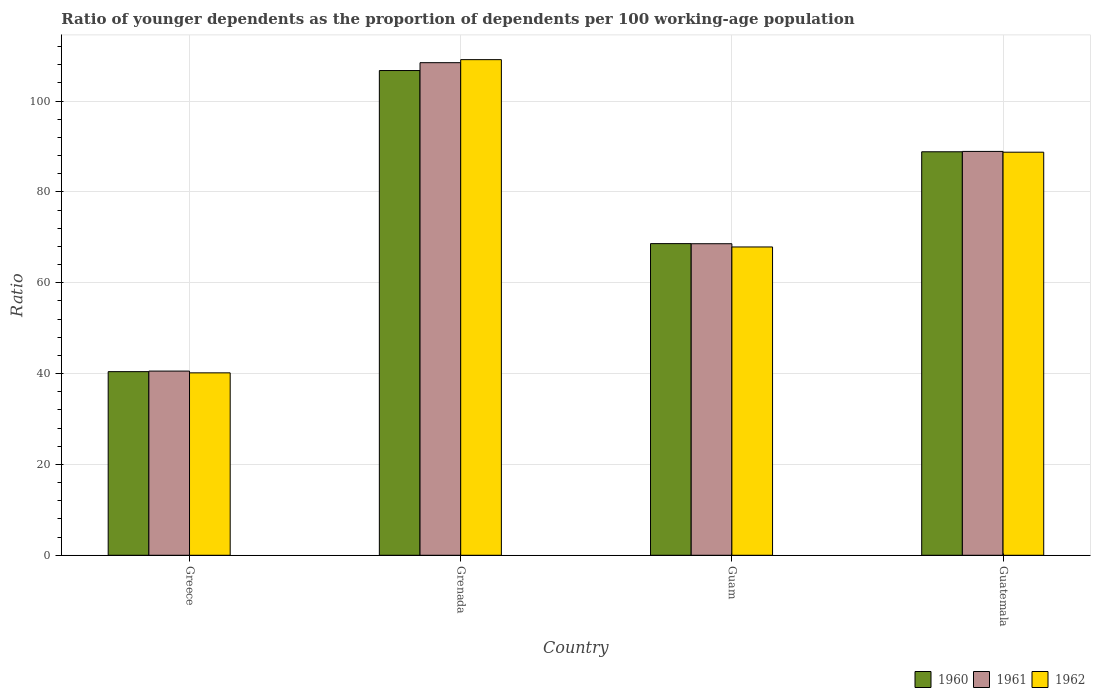How many different coloured bars are there?
Keep it short and to the point. 3. How many groups of bars are there?
Keep it short and to the point. 4. Are the number of bars per tick equal to the number of legend labels?
Your response must be concise. Yes. Are the number of bars on each tick of the X-axis equal?
Make the answer very short. Yes. How many bars are there on the 3rd tick from the right?
Give a very brief answer. 3. What is the label of the 3rd group of bars from the left?
Give a very brief answer. Guam. What is the age dependency ratio(young) in 1962 in Guatemala?
Make the answer very short. 88.73. Across all countries, what is the maximum age dependency ratio(young) in 1962?
Provide a short and direct response. 109.11. Across all countries, what is the minimum age dependency ratio(young) in 1962?
Make the answer very short. 40.16. In which country was the age dependency ratio(young) in 1962 maximum?
Give a very brief answer. Grenada. What is the total age dependency ratio(young) in 1961 in the graph?
Give a very brief answer. 306.48. What is the difference between the age dependency ratio(young) in 1960 in Grenada and that in Guam?
Make the answer very short. 38.1. What is the difference between the age dependency ratio(young) in 1961 in Greece and the age dependency ratio(young) in 1960 in Grenada?
Your response must be concise. -66.16. What is the average age dependency ratio(young) in 1962 per country?
Ensure brevity in your answer.  76.47. What is the difference between the age dependency ratio(young) of/in 1962 and age dependency ratio(young) of/in 1961 in Guatemala?
Your answer should be very brief. -0.17. What is the ratio of the age dependency ratio(young) in 1961 in Grenada to that in Guam?
Your answer should be very brief. 1.58. Is the age dependency ratio(young) in 1962 in Guam less than that in Guatemala?
Your answer should be very brief. Yes. What is the difference between the highest and the second highest age dependency ratio(young) in 1960?
Offer a terse response. -17.88. What is the difference between the highest and the lowest age dependency ratio(young) in 1962?
Provide a short and direct response. 68.95. Is the sum of the age dependency ratio(young) in 1961 in Greece and Guatemala greater than the maximum age dependency ratio(young) in 1962 across all countries?
Your answer should be very brief. Yes. What does the 2nd bar from the left in Guatemala represents?
Your response must be concise. 1961. What does the 2nd bar from the right in Guam represents?
Offer a terse response. 1961. Is it the case that in every country, the sum of the age dependency ratio(young) in 1961 and age dependency ratio(young) in 1962 is greater than the age dependency ratio(young) in 1960?
Ensure brevity in your answer.  Yes. What is the difference between two consecutive major ticks on the Y-axis?
Offer a terse response. 20. Does the graph contain grids?
Offer a very short reply. Yes. Where does the legend appear in the graph?
Your answer should be compact. Bottom right. How many legend labels are there?
Keep it short and to the point. 3. What is the title of the graph?
Your answer should be very brief. Ratio of younger dependents as the proportion of dependents per 100 working-age population. Does "2011" appear as one of the legend labels in the graph?
Ensure brevity in your answer.  No. What is the label or title of the Y-axis?
Your answer should be very brief. Ratio. What is the Ratio of 1960 in Greece?
Make the answer very short. 40.42. What is the Ratio in 1961 in Greece?
Ensure brevity in your answer.  40.55. What is the Ratio of 1962 in Greece?
Offer a terse response. 40.16. What is the Ratio of 1960 in Grenada?
Give a very brief answer. 106.71. What is the Ratio in 1961 in Grenada?
Offer a very short reply. 108.44. What is the Ratio of 1962 in Grenada?
Provide a succinct answer. 109.11. What is the Ratio in 1960 in Guam?
Your answer should be compact. 68.61. What is the Ratio of 1961 in Guam?
Make the answer very short. 68.58. What is the Ratio of 1962 in Guam?
Make the answer very short. 67.87. What is the Ratio in 1960 in Guatemala?
Offer a very short reply. 88.83. What is the Ratio in 1961 in Guatemala?
Make the answer very short. 88.91. What is the Ratio in 1962 in Guatemala?
Provide a succinct answer. 88.73. Across all countries, what is the maximum Ratio of 1960?
Your answer should be compact. 106.71. Across all countries, what is the maximum Ratio of 1961?
Keep it short and to the point. 108.44. Across all countries, what is the maximum Ratio in 1962?
Offer a very short reply. 109.11. Across all countries, what is the minimum Ratio of 1960?
Ensure brevity in your answer.  40.42. Across all countries, what is the minimum Ratio of 1961?
Give a very brief answer. 40.55. Across all countries, what is the minimum Ratio of 1962?
Provide a short and direct response. 40.16. What is the total Ratio of 1960 in the graph?
Offer a terse response. 304.56. What is the total Ratio in 1961 in the graph?
Keep it short and to the point. 306.48. What is the total Ratio of 1962 in the graph?
Ensure brevity in your answer.  305.87. What is the difference between the Ratio of 1960 in Greece and that in Grenada?
Keep it short and to the point. -66.29. What is the difference between the Ratio in 1961 in Greece and that in Grenada?
Your answer should be compact. -67.89. What is the difference between the Ratio of 1962 in Greece and that in Grenada?
Offer a very short reply. -68.95. What is the difference between the Ratio in 1960 in Greece and that in Guam?
Keep it short and to the point. -28.18. What is the difference between the Ratio of 1961 in Greece and that in Guam?
Offer a very short reply. -28.04. What is the difference between the Ratio of 1962 in Greece and that in Guam?
Your answer should be compact. -27.71. What is the difference between the Ratio of 1960 in Greece and that in Guatemala?
Your answer should be compact. -48.4. What is the difference between the Ratio of 1961 in Greece and that in Guatemala?
Your response must be concise. -48.36. What is the difference between the Ratio in 1962 in Greece and that in Guatemala?
Provide a short and direct response. -48.57. What is the difference between the Ratio of 1960 in Grenada and that in Guam?
Your answer should be very brief. 38.1. What is the difference between the Ratio in 1961 in Grenada and that in Guam?
Provide a short and direct response. 39.86. What is the difference between the Ratio of 1962 in Grenada and that in Guam?
Keep it short and to the point. 41.23. What is the difference between the Ratio in 1960 in Grenada and that in Guatemala?
Give a very brief answer. 17.88. What is the difference between the Ratio in 1961 in Grenada and that in Guatemala?
Make the answer very short. 19.53. What is the difference between the Ratio in 1962 in Grenada and that in Guatemala?
Give a very brief answer. 20.37. What is the difference between the Ratio in 1960 in Guam and that in Guatemala?
Offer a terse response. -20.22. What is the difference between the Ratio in 1961 in Guam and that in Guatemala?
Provide a succinct answer. -20.32. What is the difference between the Ratio in 1962 in Guam and that in Guatemala?
Your response must be concise. -20.86. What is the difference between the Ratio in 1960 in Greece and the Ratio in 1961 in Grenada?
Offer a very short reply. -68.02. What is the difference between the Ratio of 1960 in Greece and the Ratio of 1962 in Grenada?
Give a very brief answer. -68.68. What is the difference between the Ratio in 1961 in Greece and the Ratio in 1962 in Grenada?
Provide a succinct answer. -68.56. What is the difference between the Ratio in 1960 in Greece and the Ratio in 1961 in Guam?
Provide a succinct answer. -28.16. What is the difference between the Ratio in 1960 in Greece and the Ratio in 1962 in Guam?
Offer a very short reply. -27.45. What is the difference between the Ratio of 1961 in Greece and the Ratio of 1962 in Guam?
Your response must be concise. -27.32. What is the difference between the Ratio in 1960 in Greece and the Ratio in 1961 in Guatemala?
Your answer should be very brief. -48.48. What is the difference between the Ratio in 1960 in Greece and the Ratio in 1962 in Guatemala?
Offer a terse response. -48.31. What is the difference between the Ratio of 1961 in Greece and the Ratio of 1962 in Guatemala?
Your response must be concise. -48.19. What is the difference between the Ratio in 1960 in Grenada and the Ratio in 1961 in Guam?
Keep it short and to the point. 38.13. What is the difference between the Ratio in 1960 in Grenada and the Ratio in 1962 in Guam?
Your answer should be very brief. 38.84. What is the difference between the Ratio of 1961 in Grenada and the Ratio of 1962 in Guam?
Offer a very short reply. 40.57. What is the difference between the Ratio in 1960 in Grenada and the Ratio in 1961 in Guatemala?
Give a very brief answer. 17.8. What is the difference between the Ratio in 1960 in Grenada and the Ratio in 1962 in Guatemala?
Ensure brevity in your answer.  17.98. What is the difference between the Ratio of 1961 in Grenada and the Ratio of 1962 in Guatemala?
Provide a short and direct response. 19.71. What is the difference between the Ratio of 1960 in Guam and the Ratio of 1961 in Guatemala?
Offer a very short reply. -20.3. What is the difference between the Ratio of 1960 in Guam and the Ratio of 1962 in Guatemala?
Make the answer very short. -20.13. What is the difference between the Ratio in 1961 in Guam and the Ratio in 1962 in Guatemala?
Make the answer very short. -20.15. What is the average Ratio of 1960 per country?
Ensure brevity in your answer.  76.14. What is the average Ratio of 1961 per country?
Ensure brevity in your answer.  76.62. What is the average Ratio of 1962 per country?
Keep it short and to the point. 76.47. What is the difference between the Ratio in 1960 and Ratio in 1961 in Greece?
Provide a succinct answer. -0.12. What is the difference between the Ratio of 1960 and Ratio of 1962 in Greece?
Keep it short and to the point. 0.26. What is the difference between the Ratio in 1961 and Ratio in 1962 in Greece?
Your response must be concise. 0.39. What is the difference between the Ratio in 1960 and Ratio in 1961 in Grenada?
Your response must be concise. -1.73. What is the difference between the Ratio of 1960 and Ratio of 1962 in Grenada?
Provide a short and direct response. -2.4. What is the difference between the Ratio in 1961 and Ratio in 1962 in Grenada?
Your answer should be very brief. -0.67. What is the difference between the Ratio in 1960 and Ratio in 1961 in Guam?
Ensure brevity in your answer.  0.02. What is the difference between the Ratio in 1960 and Ratio in 1962 in Guam?
Provide a succinct answer. 0.74. What is the difference between the Ratio of 1961 and Ratio of 1962 in Guam?
Give a very brief answer. 0.71. What is the difference between the Ratio of 1960 and Ratio of 1961 in Guatemala?
Your answer should be compact. -0.08. What is the difference between the Ratio of 1960 and Ratio of 1962 in Guatemala?
Your answer should be very brief. 0.09. What is the difference between the Ratio in 1961 and Ratio in 1962 in Guatemala?
Provide a short and direct response. 0.17. What is the ratio of the Ratio in 1960 in Greece to that in Grenada?
Make the answer very short. 0.38. What is the ratio of the Ratio of 1961 in Greece to that in Grenada?
Make the answer very short. 0.37. What is the ratio of the Ratio in 1962 in Greece to that in Grenada?
Ensure brevity in your answer.  0.37. What is the ratio of the Ratio in 1960 in Greece to that in Guam?
Your response must be concise. 0.59. What is the ratio of the Ratio of 1961 in Greece to that in Guam?
Your answer should be compact. 0.59. What is the ratio of the Ratio of 1962 in Greece to that in Guam?
Keep it short and to the point. 0.59. What is the ratio of the Ratio of 1960 in Greece to that in Guatemala?
Offer a terse response. 0.46. What is the ratio of the Ratio of 1961 in Greece to that in Guatemala?
Provide a short and direct response. 0.46. What is the ratio of the Ratio of 1962 in Greece to that in Guatemala?
Your answer should be compact. 0.45. What is the ratio of the Ratio of 1960 in Grenada to that in Guam?
Provide a short and direct response. 1.56. What is the ratio of the Ratio in 1961 in Grenada to that in Guam?
Provide a short and direct response. 1.58. What is the ratio of the Ratio in 1962 in Grenada to that in Guam?
Your answer should be compact. 1.61. What is the ratio of the Ratio of 1960 in Grenada to that in Guatemala?
Your answer should be very brief. 1.2. What is the ratio of the Ratio in 1961 in Grenada to that in Guatemala?
Your answer should be compact. 1.22. What is the ratio of the Ratio in 1962 in Grenada to that in Guatemala?
Offer a very short reply. 1.23. What is the ratio of the Ratio of 1960 in Guam to that in Guatemala?
Your answer should be compact. 0.77. What is the ratio of the Ratio of 1961 in Guam to that in Guatemala?
Your answer should be very brief. 0.77. What is the ratio of the Ratio in 1962 in Guam to that in Guatemala?
Keep it short and to the point. 0.76. What is the difference between the highest and the second highest Ratio in 1960?
Ensure brevity in your answer.  17.88. What is the difference between the highest and the second highest Ratio in 1961?
Provide a short and direct response. 19.53. What is the difference between the highest and the second highest Ratio in 1962?
Your answer should be compact. 20.37. What is the difference between the highest and the lowest Ratio of 1960?
Ensure brevity in your answer.  66.29. What is the difference between the highest and the lowest Ratio of 1961?
Your answer should be compact. 67.89. What is the difference between the highest and the lowest Ratio in 1962?
Your response must be concise. 68.95. 